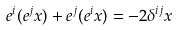Convert formula to latex. <formula><loc_0><loc_0><loc_500><loc_500>e ^ { i } ( e ^ { j } x ) + e ^ { j } ( e ^ { i } x ) = - 2 \delta ^ { i j } x</formula> 